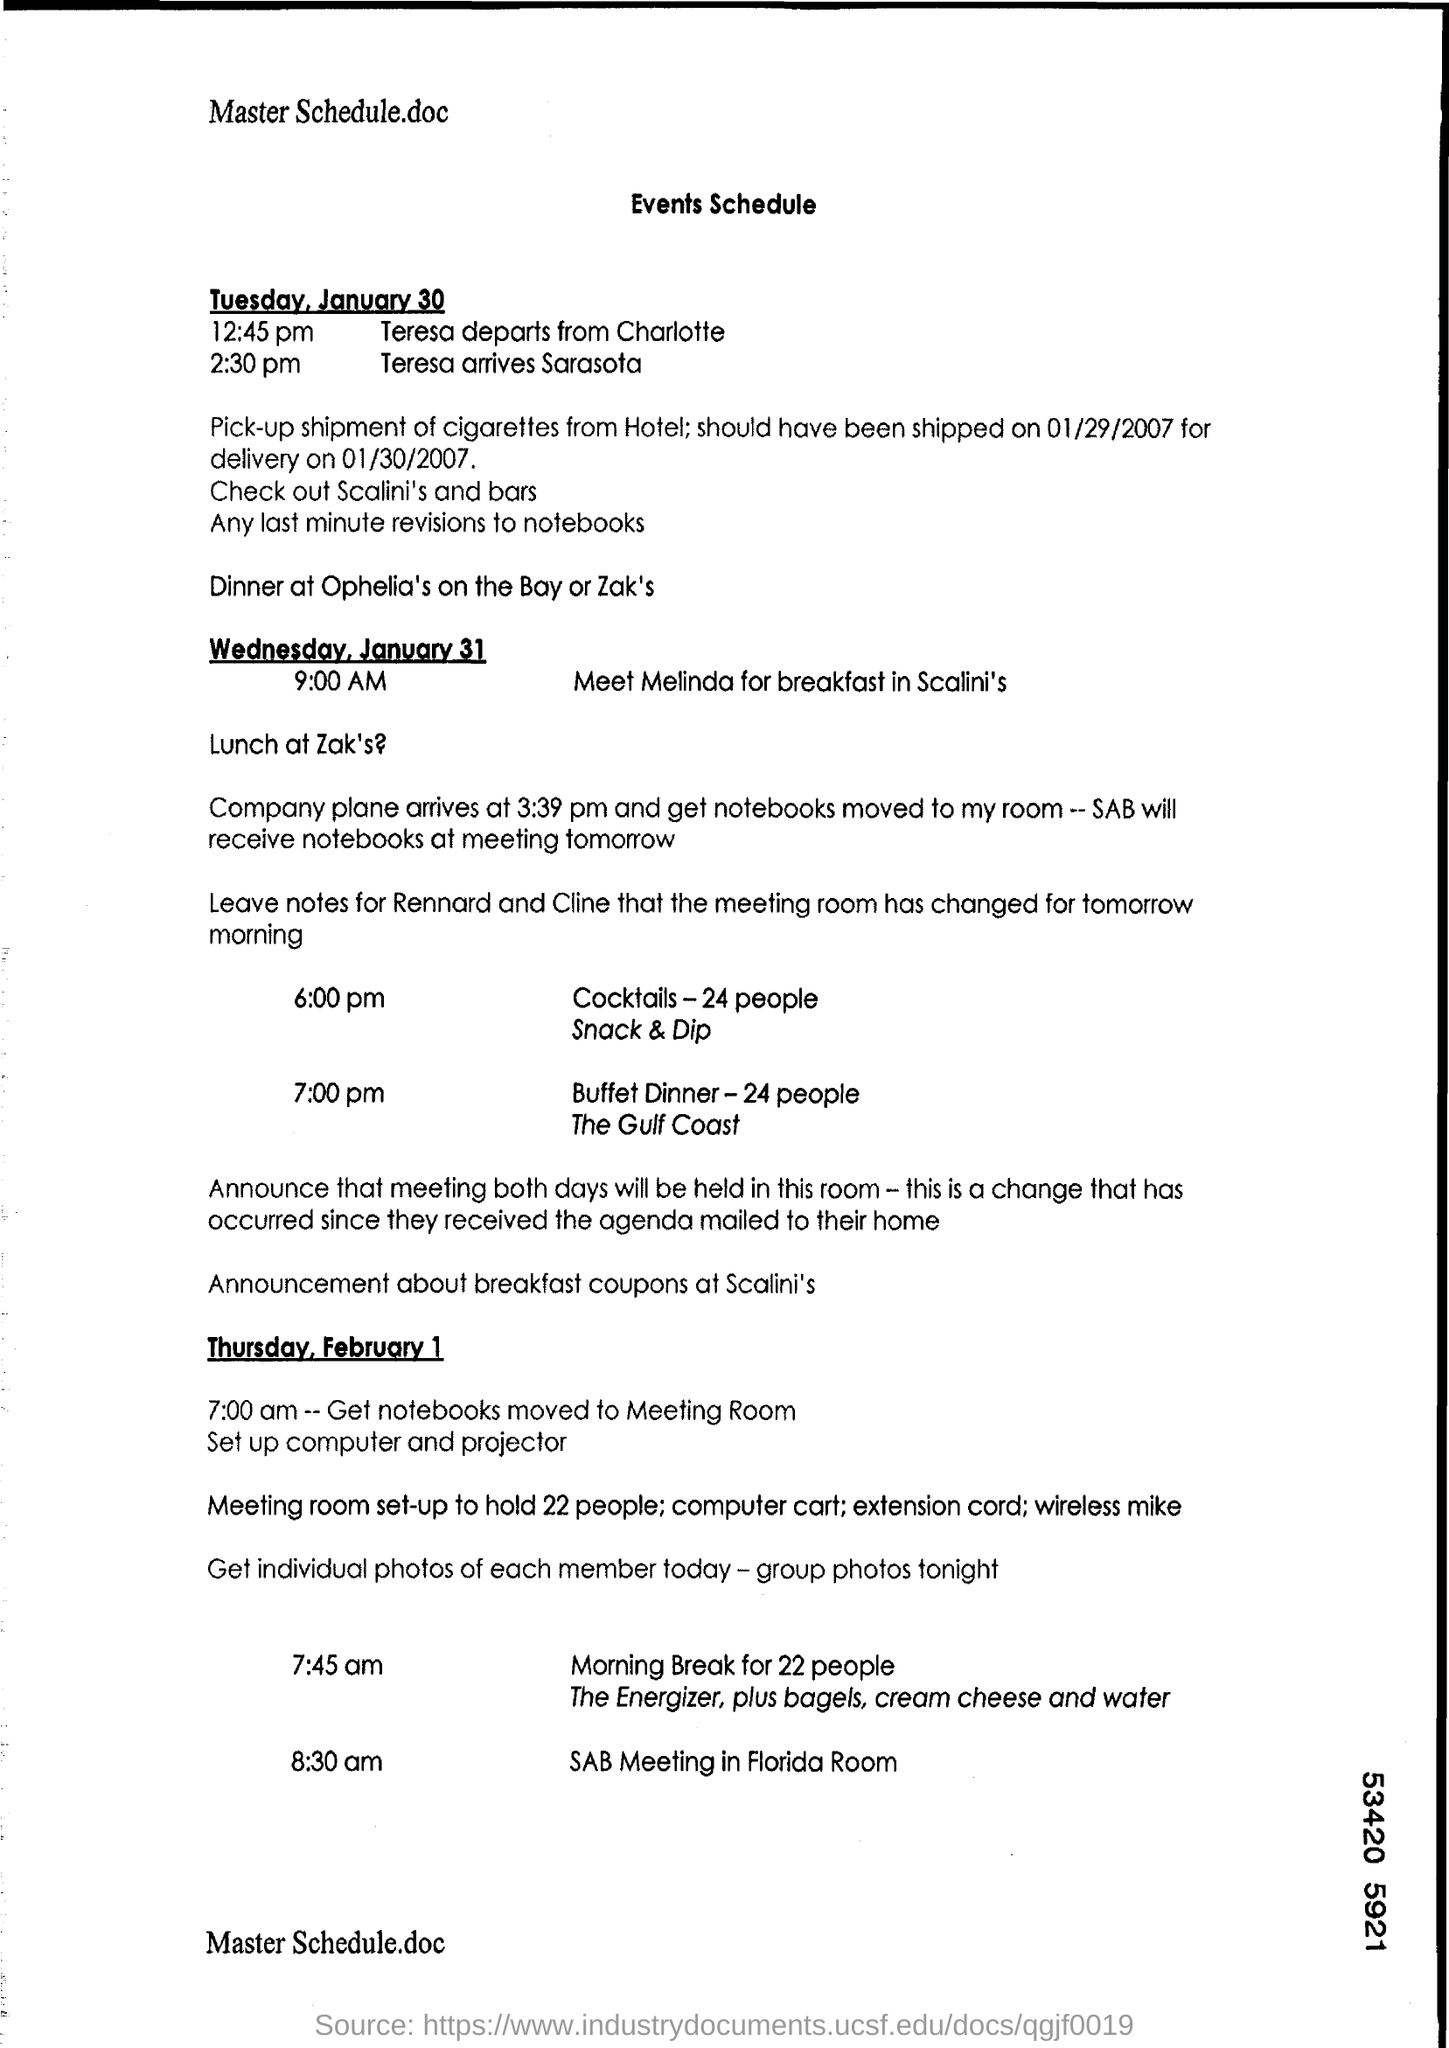What is the arrival time of teresa at sarasota?
Offer a terse response. 2:30 pm. 